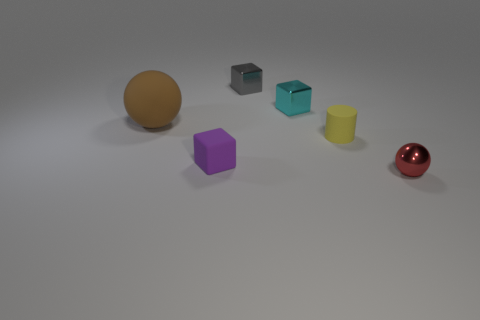Do the shiny thing in front of the big thing and the big brown thing have the same shape?
Provide a short and direct response. Yes. What material is the cyan object that is the same shape as the gray shiny object?
Offer a very short reply. Metal. Is the shape of the purple matte thing the same as the tiny object that is to the right of the tiny yellow object?
Keep it short and to the point. No. What color is the rubber object that is to the left of the gray metallic block and in front of the big brown matte sphere?
Offer a terse response. Purple. Is there a small metal sphere?
Provide a short and direct response. Yes. Is the number of large brown rubber spheres to the right of the tiny purple matte object the same as the number of tiny objects?
Offer a very short reply. No. How many other objects are there of the same shape as the tiny red metal thing?
Make the answer very short. 1. What is the shape of the big brown thing?
Offer a very short reply. Sphere. Does the big thing have the same material as the cyan block?
Provide a succinct answer. No. Is the number of gray metallic things that are behind the tiny gray metal block the same as the number of metallic balls that are in front of the cyan object?
Provide a succinct answer. No. 